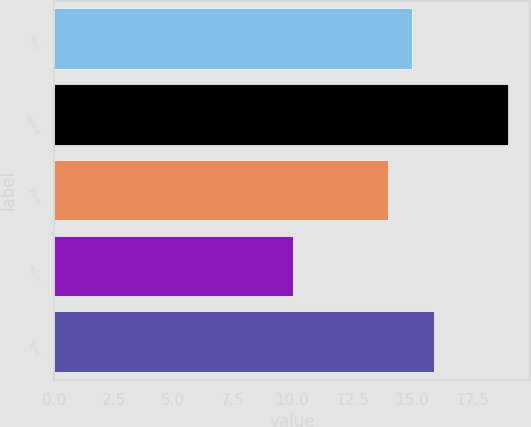<chart> <loc_0><loc_0><loc_500><loc_500><bar_chart><fcel>East<fcel>Central<fcel>West<fcel>Other<fcel>Total<nl><fcel>15<fcel>19<fcel>14<fcel>10<fcel>15.9<nl></chart> 